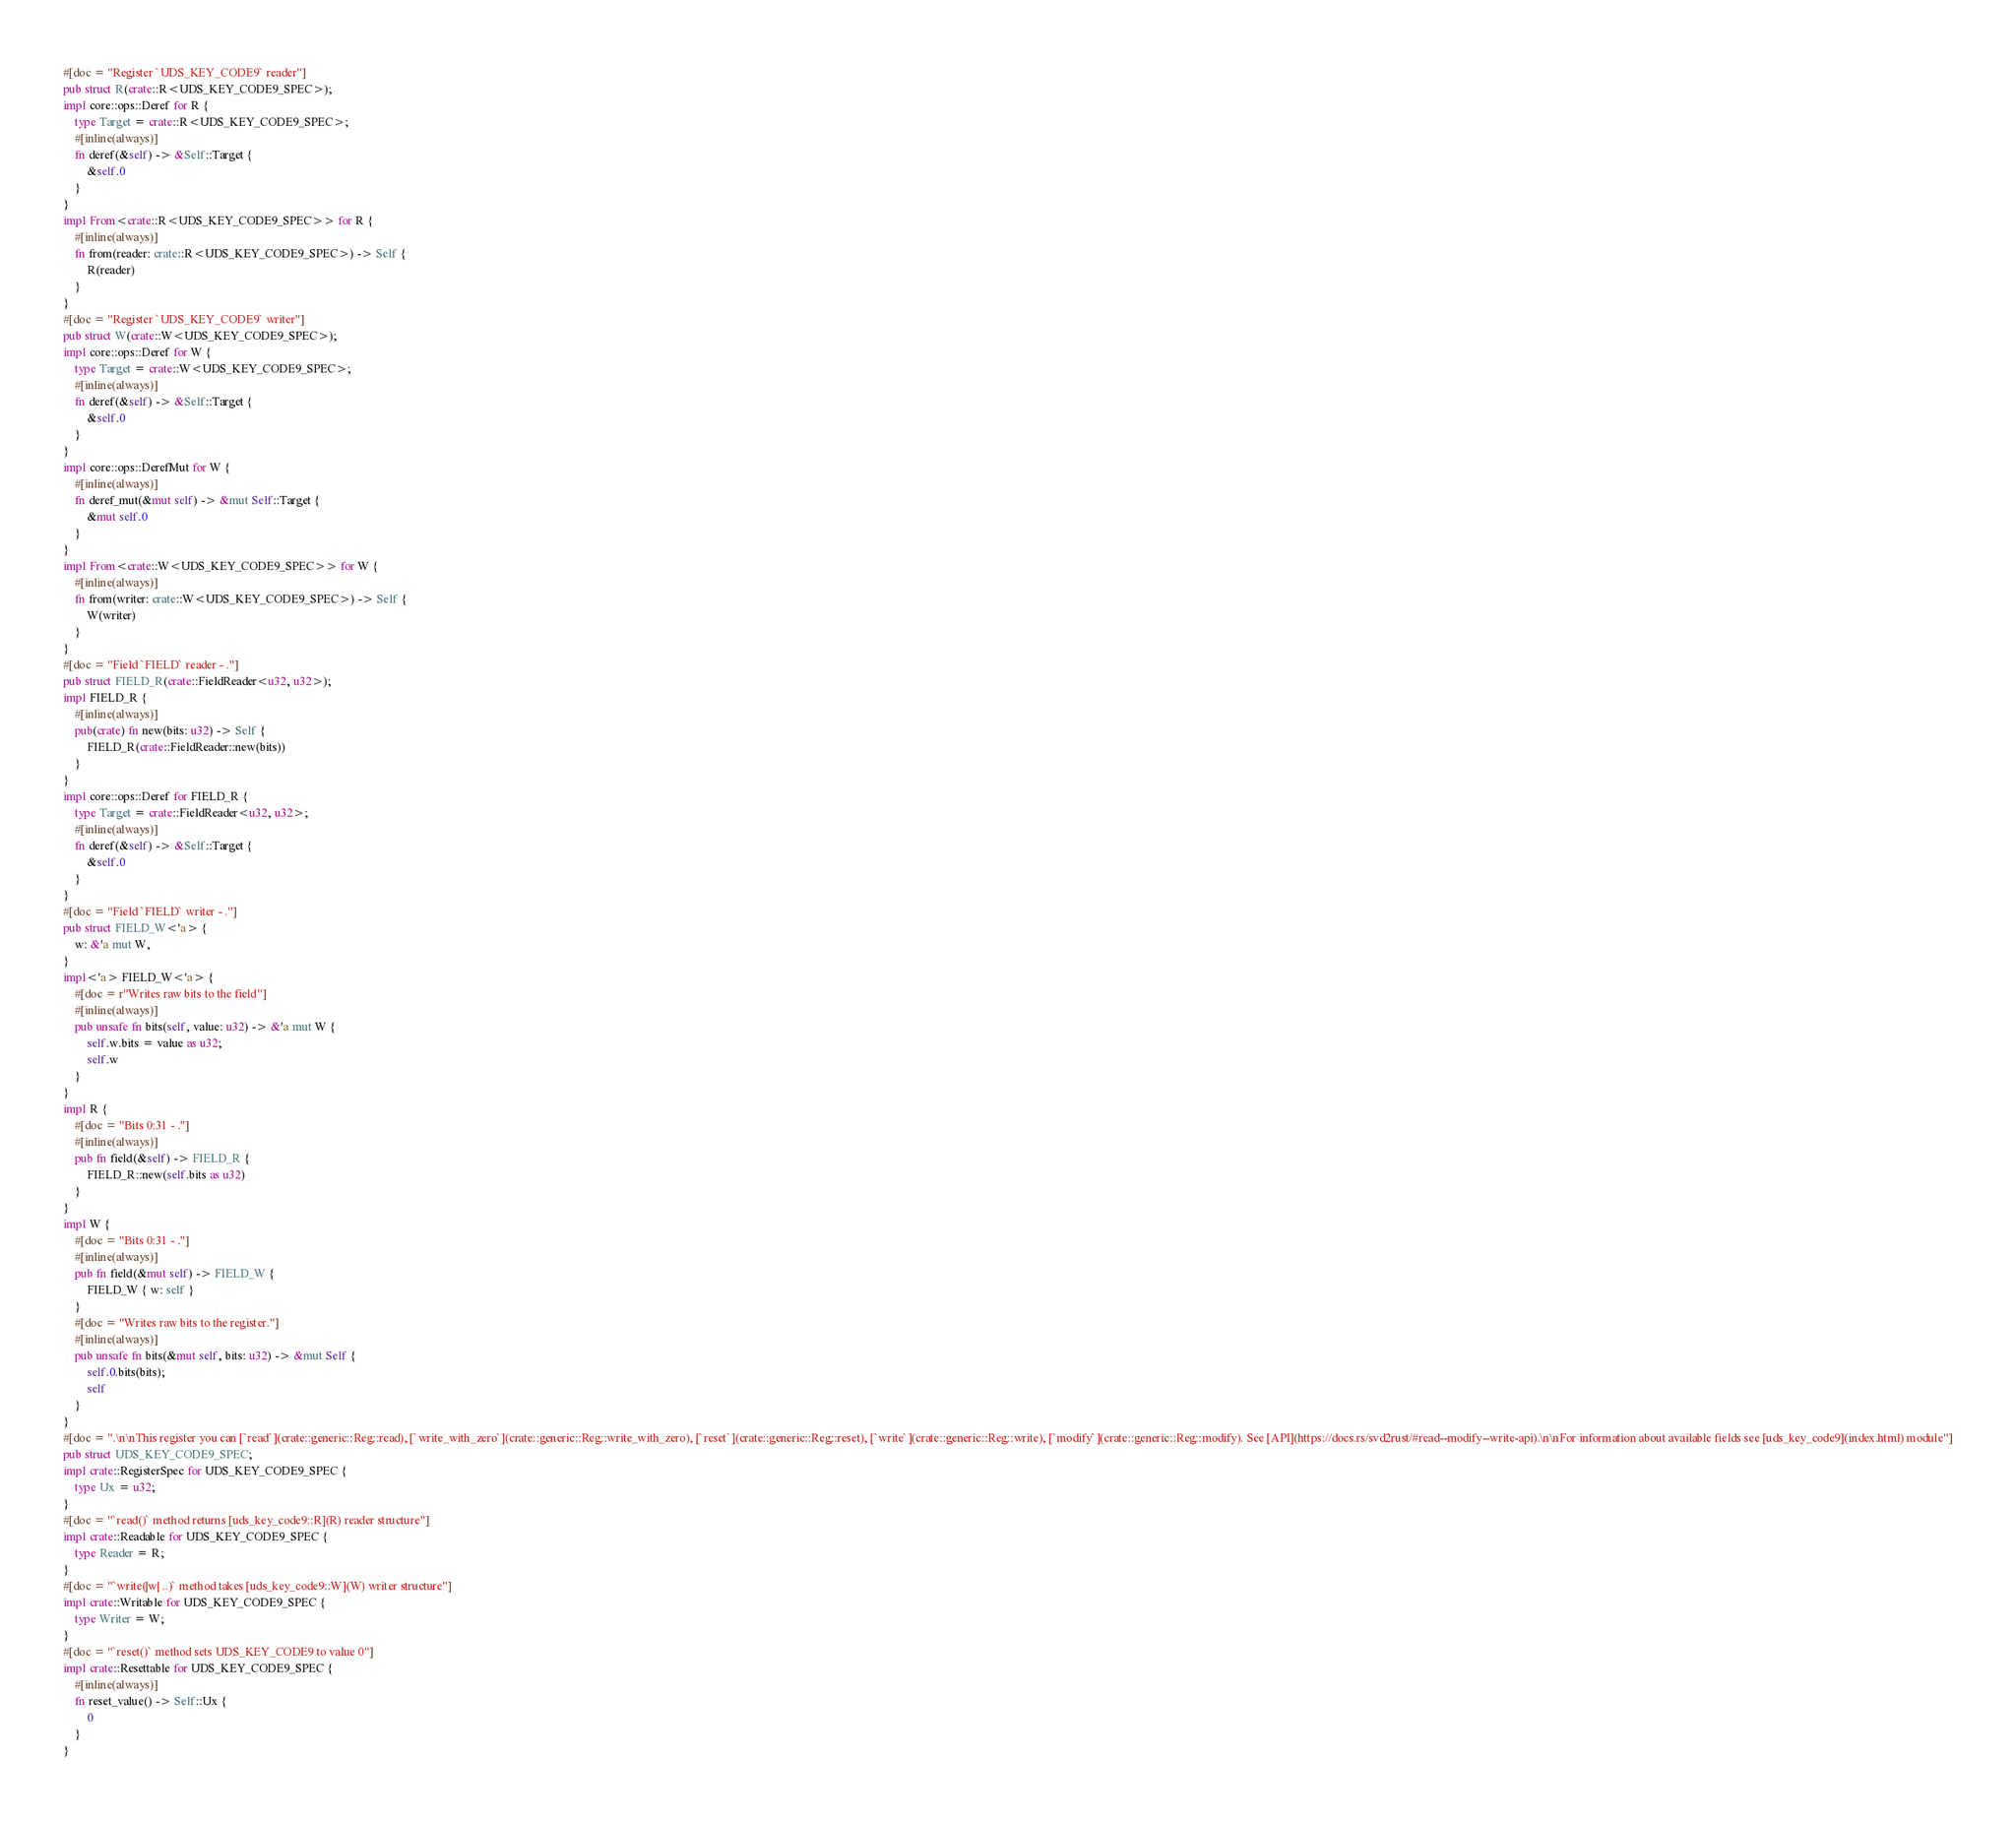Convert code to text. <code><loc_0><loc_0><loc_500><loc_500><_Rust_>#[doc = "Register `UDS_KEY_CODE9` reader"]
pub struct R(crate::R<UDS_KEY_CODE9_SPEC>);
impl core::ops::Deref for R {
    type Target = crate::R<UDS_KEY_CODE9_SPEC>;
    #[inline(always)]
    fn deref(&self) -> &Self::Target {
        &self.0
    }
}
impl From<crate::R<UDS_KEY_CODE9_SPEC>> for R {
    #[inline(always)]
    fn from(reader: crate::R<UDS_KEY_CODE9_SPEC>) -> Self {
        R(reader)
    }
}
#[doc = "Register `UDS_KEY_CODE9` writer"]
pub struct W(crate::W<UDS_KEY_CODE9_SPEC>);
impl core::ops::Deref for W {
    type Target = crate::W<UDS_KEY_CODE9_SPEC>;
    #[inline(always)]
    fn deref(&self) -> &Self::Target {
        &self.0
    }
}
impl core::ops::DerefMut for W {
    #[inline(always)]
    fn deref_mut(&mut self) -> &mut Self::Target {
        &mut self.0
    }
}
impl From<crate::W<UDS_KEY_CODE9_SPEC>> for W {
    #[inline(always)]
    fn from(writer: crate::W<UDS_KEY_CODE9_SPEC>) -> Self {
        W(writer)
    }
}
#[doc = "Field `FIELD` reader - ."]
pub struct FIELD_R(crate::FieldReader<u32, u32>);
impl FIELD_R {
    #[inline(always)]
    pub(crate) fn new(bits: u32) -> Self {
        FIELD_R(crate::FieldReader::new(bits))
    }
}
impl core::ops::Deref for FIELD_R {
    type Target = crate::FieldReader<u32, u32>;
    #[inline(always)]
    fn deref(&self) -> &Self::Target {
        &self.0
    }
}
#[doc = "Field `FIELD` writer - ."]
pub struct FIELD_W<'a> {
    w: &'a mut W,
}
impl<'a> FIELD_W<'a> {
    #[doc = r"Writes raw bits to the field"]
    #[inline(always)]
    pub unsafe fn bits(self, value: u32) -> &'a mut W {
        self.w.bits = value as u32;
        self.w
    }
}
impl R {
    #[doc = "Bits 0:31 - ."]
    #[inline(always)]
    pub fn field(&self) -> FIELD_R {
        FIELD_R::new(self.bits as u32)
    }
}
impl W {
    #[doc = "Bits 0:31 - ."]
    #[inline(always)]
    pub fn field(&mut self) -> FIELD_W {
        FIELD_W { w: self }
    }
    #[doc = "Writes raw bits to the register."]
    #[inline(always)]
    pub unsafe fn bits(&mut self, bits: u32) -> &mut Self {
        self.0.bits(bits);
        self
    }
}
#[doc = ".\n\nThis register you can [`read`](crate::generic::Reg::read), [`write_with_zero`](crate::generic::Reg::write_with_zero), [`reset`](crate::generic::Reg::reset), [`write`](crate::generic::Reg::write), [`modify`](crate::generic::Reg::modify). See [API](https://docs.rs/svd2rust/#read--modify--write-api).\n\nFor information about available fields see [uds_key_code9](index.html) module"]
pub struct UDS_KEY_CODE9_SPEC;
impl crate::RegisterSpec for UDS_KEY_CODE9_SPEC {
    type Ux = u32;
}
#[doc = "`read()` method returns [uds_key_code9::R](R) reader structure"]
impl crate::Readable for UDS_KEY_CODE9_SPEC {
    type Reader = R;
}
#[doc = "`write(|w| ..)` method takes [uds_key_code9::W](W) writer structure"]
impl crate::Writable for UDS_KEY_CODE9_SPEC {
    type Writer = W;
}
#[doc = "`reset()` method sets UDS_KEY_CODE9 to value 0"]
impl crate::Resettable for UDS_KEY_CODE9_SPEC {
    #[inline(always)]
    fn reset_value() -> Self::Ux {
        0
    }
}
</code> 